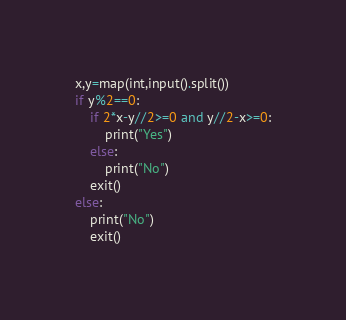<code> <loc_0><loc_0><loc_500><loc_500><_Python_>x,y=map(int,input().split())
if y%2==0:
    if 2*x-y//2>=0 and y//2-x>=0:
        print("Yes")
    else:
        print("No")
    exit()
else:
    print("No")
    exit()</code> 